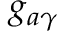<formula> <loc_0><loc_0><loc_500><loc_500>g _ { a \gamma }</formula> 